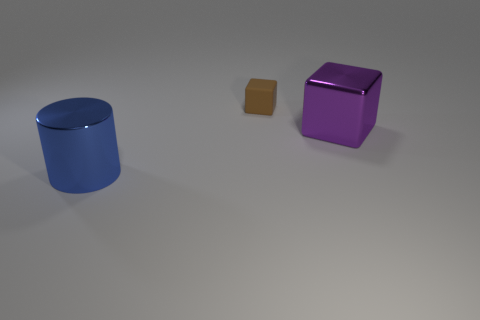Is the number of metallic cubes that are left of the tiny thing less than the number of metal cylinders on the left side of the purple object?
Provide a short and direct response. Yes. Is the shape of the big blue shiny object the same as the rubber thing?
Give a very brief answer. No. How many other things are there of the same size as the metallic block?
Ensure brevity in your answer.  1. What number of things are large shiny objects that are in front of the purple metal thing or blue cylinders in front of the large metallic cube?
Your answer should be very brief. 1. How many other big metal things have the same shape as the brown object?
Provide a succinct answer. 1. What is the material of the thing that is behind the blue metal thing and left of the big shiny cube?
Your response must be concise. Rubber. How many tiny matte blocks are in front of the big blue metal thing?
Make the answer very short. 0. How many brown shiny cylinders are there?
Your answer should be very brief. 0. Does the brown rubber cube have the same size as the blue cylinder?
Provide a short and direct response. No. Are there any tiny brown objects to the left of the large shiny object left of the small brown thing that is behind the large blue cylinder?
Give a very brief answer. No. 